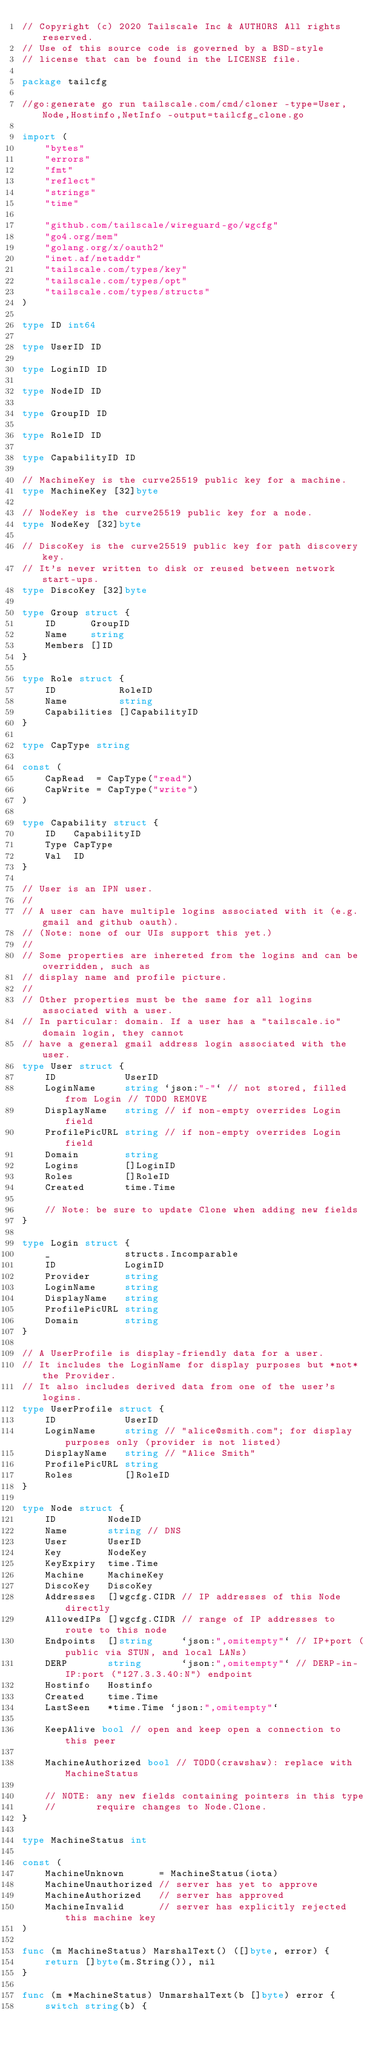Convert code to text. <code><loc_0><loc_0><loc_500><loc_500><_Go_>// Copyright (c) 2020 Tailscale Inc & AUTHORS All rights reserved.
// Use of this source code is governed by a BSD-style
// license that can be found in the LICENSE file.

package tailcfg

//go:generate go run tailscale.com/cmd/cloner -type=User,Node,Hostinfo,NetInfo -output=tailcfg_clone.go

import (
	"bytes"
	"errors"
	"fmt"
	"reflect"
	"strings"
	"time"

	"github.com/tailscale/wireguard-go/wgcfg"
	"go4.org/mem"
	"golang.org/x/oauth2"
	"inet.af/netaddr"
	"tailscale.com/types/key"
	"tailscale.com/types/opt"
	"tailscale.com/types/structs"
)

type ID int64

type UserID ID

type LoginID ID

type NodeID ID

type GroupID ID

type RoleID ID

type CapabilityID ID

// MachineKey is the curve25519 public key for a machine.
type MachineKey [32]byte

// NodeKey is the curve25519 public key for a node.
type NodeKey [32]byte

// DiscoKey is the curve25519 public key for path discovery key.
// It's never written to disk or reused between network start-ups.
type DiscoKey [32]byte

type Group struct {
	ID      GroupID
	Name    string
	Members []ID
}

type Role struct {
	ID           RoleID
	Name         string
	Capabilities []CapabilityID
}

type CapType string

const (
	CapRead  = CapType("read")
	CapWrite = CapType("write")
)

type Capability struct {
	ID   CapabilityID
	Type CapType
	Val  ID
}

// User is an IPN user.
//
// A user can have multiple logins associated with it (e.g. gmail and github oauth).
// (Note: none of our UIs support this yet.)
//
// Some properties are inhereted from the logins and can be overridden, such as
// display name and profile picture.
//
// Other properties must be the same for all logins associated with a user.
// In particular: domain. If a user has a "tailscale.io" domain login, they cannot
// have a general gmail address login associated with the user.
type User struct {
	ID            UserID
	LoginName     string `json:"-"` // not stored, filled from Login // TODO REMOVE
	DisplayName   string // if non-empty overrides Login field
	ProfilePicURL string // if non-empty overrides Login field
	Domain        string
	Logins        []LoginID
	Roles         []RoleID
	Created       time.Time

	// Note: be sure to update Clone when adding new fields
}

type Login struct {
	_             structs.Incomparable
	ID            LoginID
	Provider      string
	LoginName     string
	DisplayName   string
	ProfilePicURL string
	Domain        string
}

// A UserProfile is display-friendly data for a user.
// It includes the LoginName for display purposes but *not* the Provider.
// It also includes derived data from one of the user's logins.
type UserProfile struct {
	ID            UserID
	LoginName     string // "alice@smith.com"; for display purposes only (provider is not listed)
	DisplayName   string // "Alice Smith"
	ProfilePicURL string
	Roles         []RoleID
}

type Node struct {
	ID         NodeID
	Name       string // DNS
	User       UserID
	Key        NodeKey
	KeyExpiry  time.Time
	Machine    MachineKey
	DiscoKey   DiscoKey
	Addresses  []wgcfg.CIDR // IP addresses of this Node directly
	AllowedIPs []wgcfg.CIDR // range of IP addresses to route to this node
	Endpoints  []string     `json:",omitempty"` // IP+port (public via STUN, and local LANs)
	DERP       string       `json:",omitempty"` // DERP-in-IP:port ("127.3.3.40:N") endpoint
	Hostinfo   Hostinfo
	Created    time.Time
	LastSeen   *time.Time `json:",omitempty"`

	KeepAlive bool // open and keep open a connection to this peer

	MachineAuthorized bool // TODO(crawshaw): replace with MachineStatus

	// NOTE: any new fields containing pointers in this type
	//       require changes to Node.Clone.
}

type MachineStatus int

const (
	MachineUnknown      = MachineStatus(iota)
	MachineUnauthorized // server has yet to approve
	MachineAuthorized   // server has approved
	MachineInvalid      // server has explicitly rejected this machine key
)

func (m MachineStatus) MarshalText() ([]byte, error) {
	return []byte(m.String()), nil
}

func (m *MachineStatus) UnmarshalText(b []byte) error {
	switch string(b) {</code> 